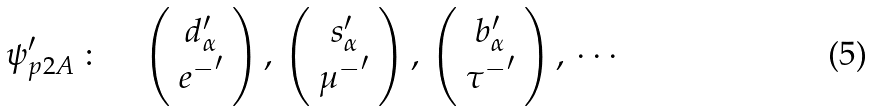<formula> <loc_0><loc_0><loc_500><loc_500>\psi ^ { \prime } _ { p 2 A } \, \colon \quad \left ( \begin{array} { c } d ^ { \prime } _ { \alpha } \\ { e ^ { - } } ^ { \prime } \end{array} \right ) , \, \left ( \begin{array} { c } s ^ { \prime } _ { \alpha } \\ { \mu ^ { - } } ^ { \prime } \end{array} \right ) , \, \left ( \begin{array} { c } b ^ { \prime } _ { \alpha } \\ { \tau ^ { - } } ^ { \prime } \end{array} \right ) , \, \cdots</formula> 